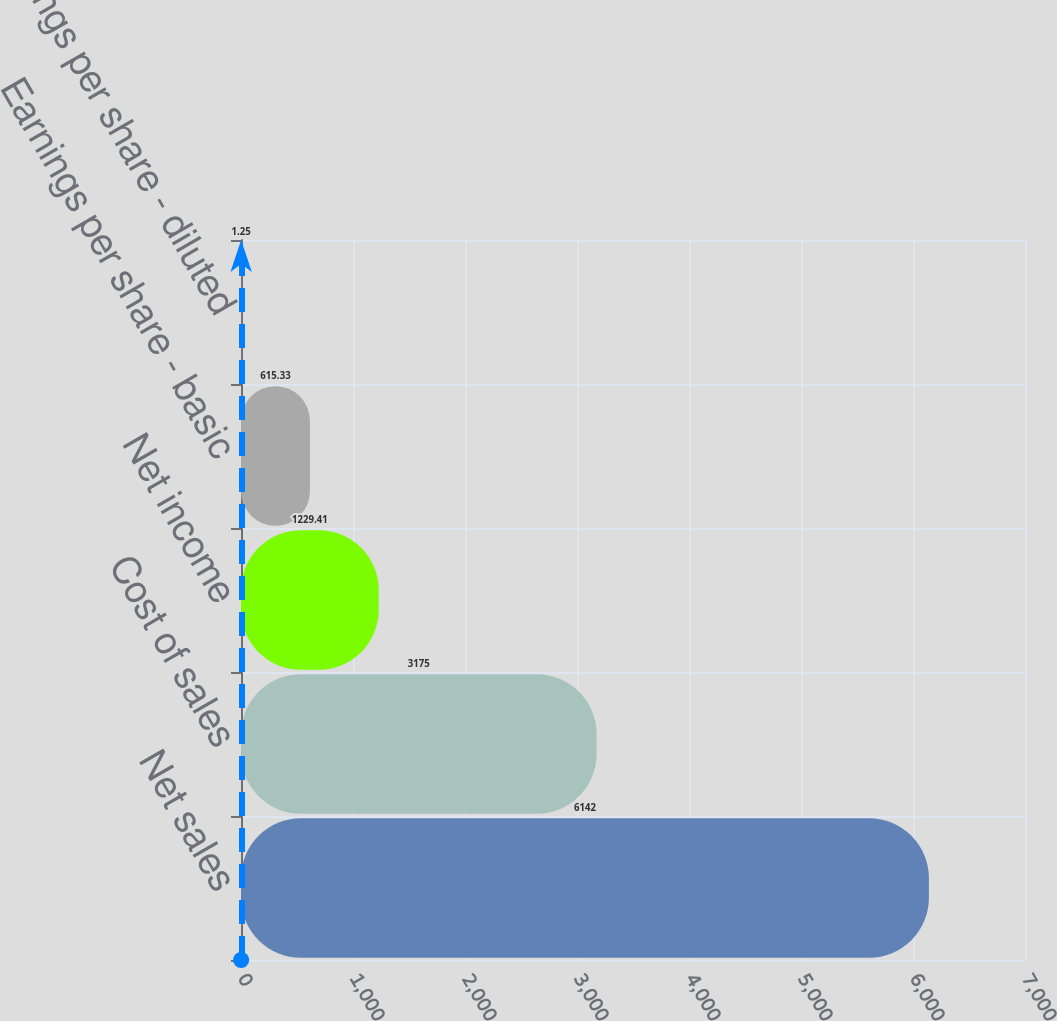Convert chart to OTSL. <chart><loc_0><loc_0><loc_500><loc_500><bar_chart><fcel>Net sales<fcel>Cost of sales<fcel>Net income<fcel>Earnings per share - basic<fcel>Earnings per share - diluted<nl><fcel>6142<fcel>3175<fcel>1229.41<fcel>615.33<fcel>1.25<nl></chart> 